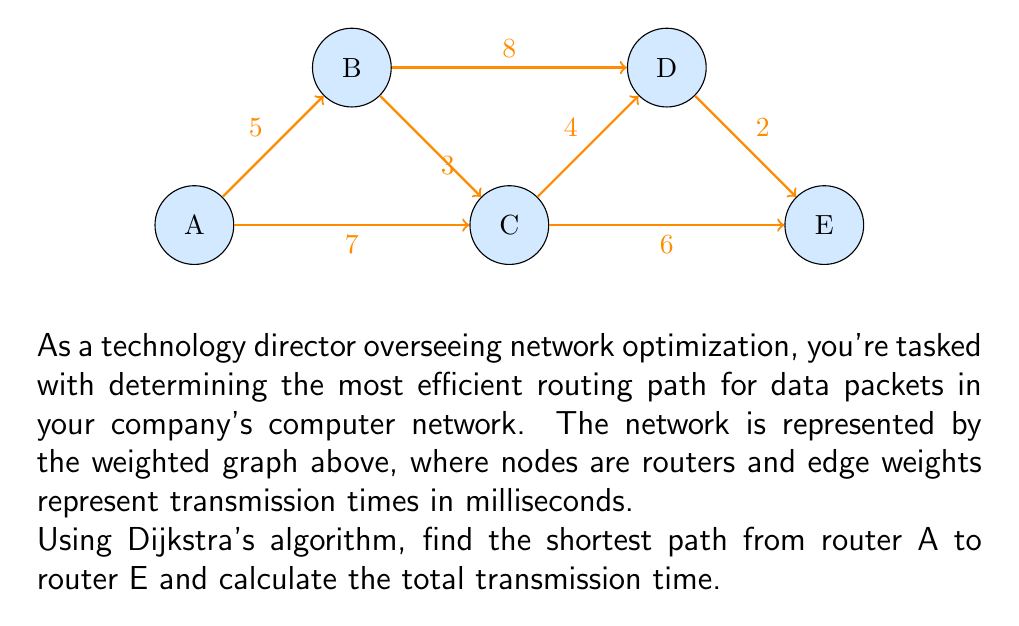Teach me how to tackle this problem. To solve this problem, we'll apply Dijkstra's algorithm to find the shortest path from A to E. Let's go through the steps:

1) Initialize:
   - Distance to A: 0
   - Distance to all other nodes: $\infty$
   - Set of unvisited nodes: {A, B, C, D, E}

2) Start from node A:
   - Update distances: A(0), B(5), C(7), D($\infty$), E($\infty$)
   - Mark A as visited
   - Unvisited set: {B, C, D, E}

3) Select node with smallest distance (B):
   - Update distances through B: D = min($\infty$, 5 + 8) = 13
   - Mark B as visited
   - Unvisited set: {C, D, E}

4) Select node with smallest distance (C):
   - Update distances through C: D = min(13, 7 + 4) = 11, E = min($\infty$, 7 + 6) = 13
   - Mark C as visited
   - Unvisited set: {D, E}

5) Select node with smallest distance (D):
   - Update distances through D: E = min(13, 11 + 2) = 13
   - Mark D as visited
   - Unvisited set: {E}

6) Select node E (only remaining node):
   - Mark E as visited
   - Algorithm complete

The shortest path is A → C → D → E with a total transmission time of 13 milliseconds.
Answer: A → C → D → E, 13 ms 